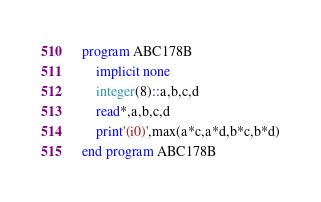Convert code to text. <code><loc_0><loc_0><loc_500><loc_500><_FORTRAN_>program ABC178B
    implicit none
    integer(8)::a,b,c,d
    read*,a,b,c,d
    print'(i0)',max(a*c,a*d,b*c,b*d)
end program ABC178B</code> 